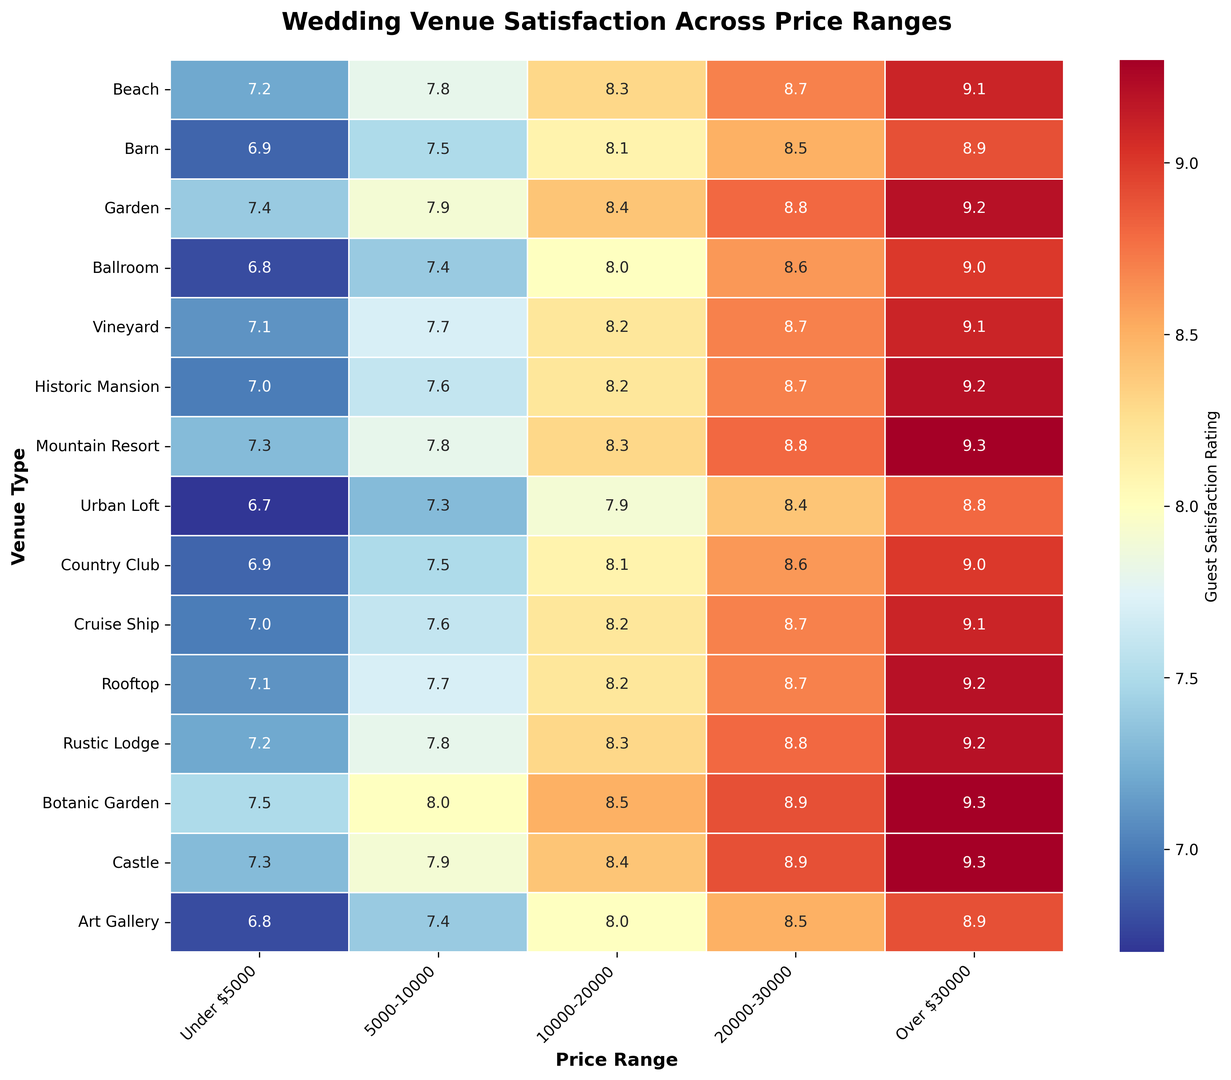Which venue type has the highest guest satisfaction rating for weddings costing over $30,000? Look for the venue type with the highest satisfaction number in the "Over $30,000" column. Both Botanic Garden, Mountain Resort, and Castle have ratings of 9.3, which are the highest.
Answer: Botanic Garden, Mountain Resort, Castle How does guest satisfaction for Urban Loft weddings at $10,000-$20,000 compare to Beach weddings at the same price? Compare the satisfaction ratings in the $10,000-$20,000 column for both Urban Loft (7.9) and Beach (8.3). Beach has a higher rating.
Answer: Beach is higher What is the average guest satisfaction rating for Barn venues across all price ranges? Add all the satisfaction ratings for Barn (6.9 + 7.5 + 8.1 + 8.5 + 8.9) and divide by the number of price ranges (5). The average is (6.9 + 7.5 + 8.1 + 8.5 + 8.9) / 5 = 7.98.
Answer: 7.98 Which venues have a satisfaction rating of 8.2 in the price range of $10,000-$20,000? Identify which venues have a rating of 8.2 in the $10,000-$20,000 column. These venues are Historic Mansion, Vineyard, Cruise Ship, Rooftop.
Answer: Historic Mansion, Vineyard, Cruise Ship, Rooftop What is the difference in satisfaction ratings between Garden venues and Botanic Garden at the $20,000-$30,000 price range? Subtract the Garden venue's rating from Botanic Garden's rating in the $20,000-$30,000 price range. The difference is (8.9 - 8.8) = 0.1.
Answer: 0.1 